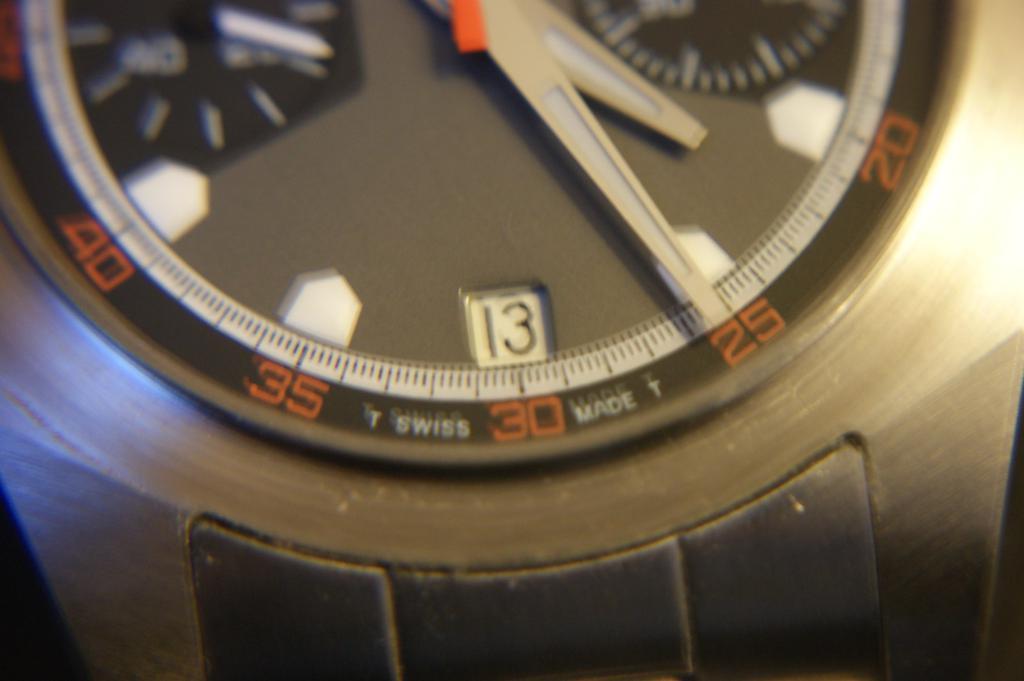What number is the minute hand pointed at?
Your answer should be compact. 25. Who made this watch?
Your answer should be compact. Swiss. 